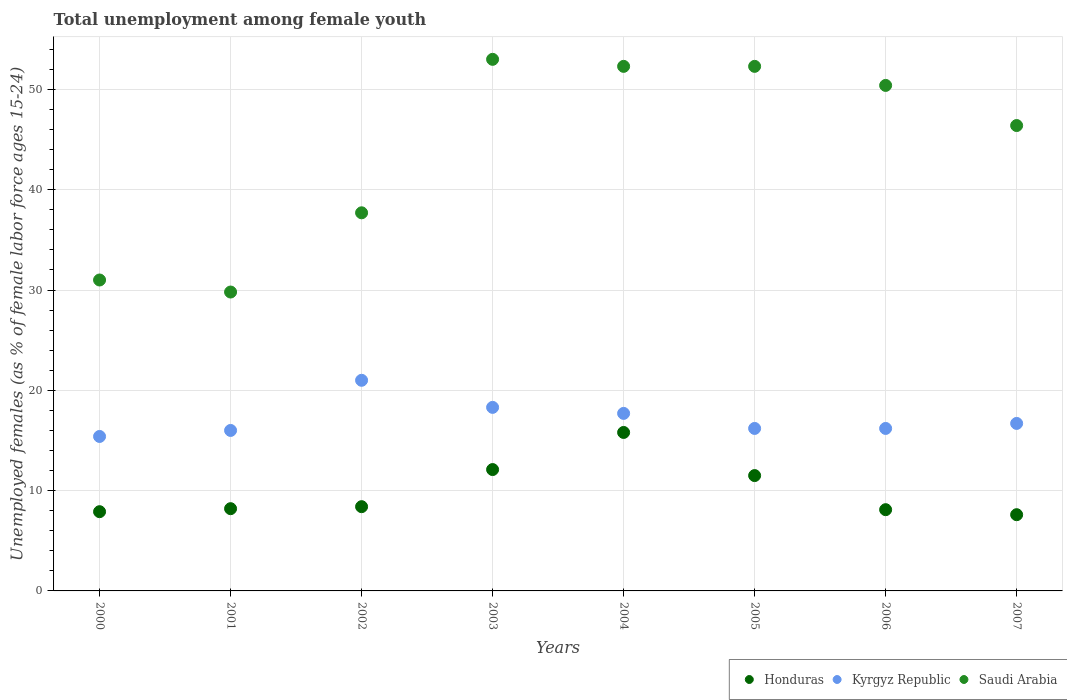How many different coloured dotlines are there?
Keep it short and to the point. 3. What is the percentage of unemployed females in in Kyrgyz Republic in 2004?
Offer a terse response. 17.7. Across all years, what is the maximum percentage of unemployed females in in Kyrgyz Republic?
Make the answer very short. 21. Across all years, what is the minimum percentage of unemployed females in in Kyrgyz Republic?
Ensure brevity in your answer.  15.4. What is the total percentage of unemployed females in in Honduras in the graph?
Provide a short and direct response. 79.6. What is the difference between the percentage of unemployed females in in Saudi Arabia in 2001 and that in 2002?
Ensure brevity in your answer.  -7.9. What is the average percentage of unemployed females in in Honduras per year?
Make the answer very short. 9.95. In the year 2002, what is the difference between the percentage of unemployed females in in Saudi Arabia and percentage of unemployed females in in Kyrgyz Republic?
Give a very brief answer. 16.7. What is the ratio of the percentage of unemployed females in in Saudi Arabia in 2004 to that in 2005?
Your response must be concise. 1. Is the percentage of unemployed females in in Kyrgyz Republic in 2003 less than that in 2005?
Your answer should be compact. No. Is the difference between the percentage of unemployed females in in Saudi Arabia in 2005 and 2006 greater than the difference between the percentage of unemployed females in in Kyrgyz Republic in 2005 and 2006?
Make the answer very short. Yes. What is the difference between the highest and the second highest percentage of unemployed females in in Kyrgyz Republic?
Your answer should be compact. 2.7. What is the difference between the highest and the lowest percentage of unemployed females in in Honduras?
Offer a terse response. 8.2. In how many years, is the percentage of unemployed females in in Honduras greater than the average percentage of unemployed females in in Honduras taken over all years?
Ensure brevity in your answer.  3. Does the percentage of unemployed females in in Kyrgyz Republic monotonically increase over the years?
Keep it short and to the point. No. Is the percentage of unemployed females in in Kyrgyz Republic strictly greater than the percentage of unemployed females in in Honduras over the years?
Offer a terse response. Yes. Is the percentage of unemployed females in in Saudi Arabia strictly less than the percentage of unemployed females in in Honduras over the years?
Provide a succinct answer. No. What is the difference between two consecutive major ticks on the Y-axis?
Ensure brevity in your answer.  10. Does the graph contain grids?
Give a very brief answer. Yes. How many legend labels are there?
Provide a succinct answer. 3. How are the legend labels stacked?
Offer a terse response. Horizontal. What is the title of the graph?
Your answer should be compact. Total unemployment among female youth. Does "Guinea" appear as one of the legend labels in the graph?
Your response must be concise. No. What is the label or title of the Y-axis?
Give a very brief answer. Unemployed females (as % of female labor force ages 15-24). What is the Unemployed females (as % of female labor force ages 15-24) in Honduras in 2000?
Provide a short and direct response. 7.9. What is the Unemployed females (as % of female labor force ages 15-24) in Kyrgyz Republic in 2000?
Provide a succinct answer. 15.4. What is the Unemployed females (as % of female labor force ages 15-24) of Honduras in 2001?
Provide a short and direct response. 8.2. What is the Unemployed females (as % of female labor force ages 15-24) of Saudi Arabia in 2001?
Ensure brevity in your answer.  29.8. What is the Unemployed females (as % of female labor force ages 15-24) in Honduras in 2002?
Give a very brief answer. 8.4. What is the Unemployed females (as % of female labor force ages 15-24) in Kyrgyz Republic in 2002?
Your response must be concise. 21. What is the Unemployed females (as % of female labor force ages 15-24) of Saudi Arabia in 2002?
Your answer should be compact. 37.7. What is the Unemployed females (as % of female labor force ages 15-24) in Honduras in 2003?
Your response must be concise. 12.1. What is the Unemployed females (as % of female labor force ages 15-24) in Kyrgyz Republic in 2003?
Ensure brevity in your answer.  18.3. What is the Unemployed females (as % of female labor force ages 15-24) in Saudi Arabia in 2003?
Keep it short and to the point. 53. What is the Unemployed females (as % of female labor force ages 15-24) of Honduras in 2004?
Provide a short and direct response. 15.8. What is the Unemployed females (as % of female labor force ages 15-24) of Kyrgyz Republic in 2004?
Give a very brief answer. 17.7. What is the Unemployed females (as % of female labor force ages 15-24) of Saudi Arabia in 2004?
Provide a succinct answer. 52.3. What is the Unemployed females (as % of female labor force ages 15-24) in Kyrgyz Republic in 2005?
Offer a very short reply. 16.2. What is the Unemployed females (as % of female labor force ages 15-24) of Saudi Arabia in 2005?
Keep it short and to the point. 52.3. What is the Unemployed females (as % of female labor force ages 15-24) of Honduras in 2006?
Provide a short and direct response. 8.1. What is the Unemployed females (as % of female labor force ages 15-24) in Kyrgyz Republic in 2006?
Provide a short and direct response. 16.2. What is the Unemployed females (as % of female labor force ages 15-24) of Saudi Arabia in 2006?
Your answer should be very brief. 50.4. What is the Unemployed females (as % of female labor force ages 15-24) in Honduras in 2007?
Your response must be concise. 7.6. What is the Unemployed females (as % of female labor force ages 15-24) of Kyrgyz Republic in 2007?
Provide a succinct answer. 16.7. What is the Unemployed females (as % of female labor force ages 15-24) in Saudi Arabia in 2007?
Make the answer very short. 46.4. Across all years, what is the maximum Unemployed females (as % of female labor force ages 15-24) in Honduras?
Ensure brevity in your answer.  15.8. Across all years, what is the maximum Unemployed females (as % of female labor force ages 15-24) in Kyrgyz Republic?
Your answer should be very brief. 21. Across all years, what is the maximum Unemployed females (as % of female labor force ages 15-24) in Saudi Arabia?
Keep it short and to the point. 53. Across all years, what is the minimum Unemployed females (as % of female labor force ages 15-24) in Honduras?
Your answer should be very brief. 7.6. Across all years, what is the minimum Unemployed females (as % of female labor force ages 15-24) in Kyrgyz Republic?
Give a very brief answer. 15.4. Across all years, what is the minimum Unemployed females (as % of female labor force ages 15-24) in Saudi Arabia?
Give a very brief answer. 29.8. What is the total Unemployed females (as % of female labor force ages 15-24) of Honduras in the graph?
Keep it short and to the point. 79.6. What is the total Unemployed females (as % of female labor force ages 15-24) of Kyrgyz Republic in the graph?
Your answer should be compact. 137.5. What is the total Unemployed females (as % of female labor force ages 15-24) of Saudi Arabia in the graph?
Ensure brevity in your answer.  352.9. What is the difference between the Unemployed females (as % of female labor force ages 15-24) of Honduras in 2000 and that in 2002?
Your response must be concise. -0.5. What is the difference between the Unemployed females (as % of female labor force ages 15-24) of Kyrgyz Republic in 2000 and that in 2002?
Your response must be concise. -5.6. What is the difference between the Unemployed females (as % of female labor force ages 15-24) of Saudi Arabia in 2000 and that in 2002?
Offer a very short reply. -6.7. What is the difference between the Unemployed females (as % of female labor force ages 15-24) of Honduras in 2000 and that in 2004?
Your answer should be very brief. -7.9. What is the difference between the Unemployed females (as % of female labor force ages 15-24) in Saudi Arabia in 2000 and that in 2004?
Give a very brief answer. -21.3. What is the difference between the Unemployed females (as % of female labor force ages 15-24) in Honduras in 2000 and that in 2005?
Make the answer very short. -3.6. What is the difference between the Unemployed females (as % of female labor force ages 15-24) in Kyrgyz Republic in 2000 and that in 2005?
Provide a short and direct response. -0.8. What is the difference between the Unemployed females (as % of female labor force ages 15-24) of Saudi Arabia in 2000 and that in 2005?
Make the answer very short. -21.3. What is the difference between the Unemployed females (as % of female labor force ages 15-24) in Honduras in 2000 and that in 2006?
Give a very brief answer. -0.2. What is the difference between the Unemployed females (as % of female labor force ages 15-24) of Saudi Arabia in 2000 and that in 2006?
Make the answer very short. -19.4. What is the difference between the Unemployed females (as % of female labor force ages 15-24) of Honduras in 2000 and that in 2007?
Your response must be concise. 0.3. What is the difference between the Unemployed females (as % of female labor force ages 15-24) in Saudi Arabia in 2000 and that in 2007?
Provide a succinct answer. -15.4. What is the difference between the Unemployed females (as % of female labor force ages 15-24) of Kyrgyz Republic in 2001 and that in 2002?
Your response must be concise. -5. What is the difference between the Unemployed females (as % of female labor force ages 15-24) of Honduras in 2001 and that in 2003?
Provide a short and direct response. -3.9. What is the difference between the Unemployed females (as % of female labor force ages 15-24) in Saudi Arabia in 2001 and that in 2003?
Make the answer very short. -23.2. What is the difference between the Unemployed females (as % of female labor force ages 15-24) in Honduras in 2001 and that in 2004?
Your response must be concise. -7.6. What is the difference between the Unemployed females (as % of female labor force ages 15-24) in Saudi Arabia in 2001 and that in 2004?
Ensure brevity in your answer.  -22.5. What is the difference between the Unemployed females (as % of female labor force ages 15-24) in Saudi Arabia in 2001 and that in 2005?
Provide a short and direct response. -22.5. What is the difference between the Unemployed females (as % of female labor force ages 15-24) in Honduras in 2001 and that in 2006?
Give a very brief answer. 0.1. What is the difference between the Unemployed females (as % of female labor force ages 15-24) of Kyrgyz Republic in 2001 and that in 2006?
Offer a terse response. -0.2. What is the difference between the Unemployed females (as % of female labor force ages 15-24) of Saudi Arabia in 2001 and that in 2006?
Your answer should be compact. -20.6. What is the difference between the Unemployed females (as % of female labor force ages 15-24) of Honduras in 2001 and that in 2007?
Offer a very short reply. 0.6. What is the difference between the Unemployed females (as % of female labor force ages 15-24) in Kyrgyz Republic in 2001 and that in 2007?
Offer a very short reply. -0.7. What is the difference between the Unemployed females (as % of female labor force ages 15-24) of Saudi Arabia in 2001 and that in 2007?
Your response must be concise. -16.6. What is the difference between the Unemployed females (as % of female labor force ages 15-24) in Honduras in 2002 and that in 2003?
Offer a very short reply. -3.7. What is the difference between the Unemployed females (as % of female labor force ages 15-24) in Kyrgyz Republic in 2002 and that in 2003?
Offer a very short reply. 2.7. What is the difference between the Unemployed females (as % of female labor force ages 15-24) of Saudi Arabia in 2002 and that in 2003?
Ensure brevity in your answer.  -15.3. What is the difference between the Unemployed females (as % of female labor force ages 15-24) in Kyrgyz Republic in 2002 and that in 2004?
Your answer should be very brief. 3.3. What is the difference between the Unemployed females (as % of female labor force ages 15-24) of Saudi Arabia in 2002 and that in 2004?
Your answer should be very brief. -14.6. What is the difference between the Unemployed females (as % of female labor force ages 15-24) of Kyrgyz Republic in 2002 and that in 2005?
Keep it short and to the point. 4.8. What is the difference between the Unemployed females (as % of female labor force ages 15-24) in Saudi Arabia in 2002 and that in 2005?
Offer a very short reply. -14.6. What is the difference between the Unemployed females (as % of female labor force ages 15-24) of Saudi Arabia in 2002 and that in 2006?
Ensure brevity in your answer.  -12.7. What is the difference between the Unemployed females (as % of female labor force ages 15-24) in Saudi Arabia in 2002 and that in 2007?
Give a very brief answer. -8.7. What is the difference between the Unemployed females (as % of female labor force ages 15-24) in Kyrgyz Republic in 2003 and that in 2004?
Give a very brief answer. 0.6. What is the difference between the Unemployed females (as % of female labor force ages 15-24) in Kyrgyz Republic in 2003 and that in 2005?
Offer a terse response. 2.1. What is the difference between the Unemployed females (as % of female labor force ages 15-24) in Saudi Arabia in 2003 and that in 2005?
Give a very brief answer. 0.7. What is the difference between the Unemployed females (as % of female labor force ages 15-24) of Saudi Arabia in 2003 and that in 2006?
Your answer should be compact. 2.6. What is the difference between the Unemployed females (as % of female labor force ages 15-24) of Honduras in 2003 and that in 2007?
Provide a succinct answer. 4.5. What is the difference between the Unemployed females (as % of female labor force ages 15-24) in Saudi Arabia in 2003 and that in 2007?
Provide a succinct answer. 6.6. What is the difference between the Unemployed females (as % of female labor force ages 15-24) of Honduras in 2004 and that in 2005?
Provide a short and direct response. 4.3. What is the difference between the Unemployed females (as % of female labor force ages 15-24) in Honduras in 2004 and that in 2006?
Keep it short and to the point. 7.7. What is the difference between the Unemployed females (as % of female labor force ages 15-24) of Kyrgyz Republic in 2004 and that in 2006?
Provide a short and direct response. 1.5. What is the difference between the Unemployed females (as % of female labor force ages 15-24) in Saudi Arabia in 2004 and that in 2006?
Your answer should be very brief. 1.9. What is the difference between the Unemployed females (as % of female labor force ages 15-24) in Honduras in 2004 and that in 2007?
Your answer should be very brief. 8.2. What is the difference between the Unemployed females (as % of female labor force ages 15-24) in Kyrgyz Republic in 2004 and that in 2007?
Offer a terse response. 1. What is the difference between the Unemployed females (as % of female labor force ages 15-24) of Saudi Arabia in 2004 and that in 2007?
Ensure brevity in your answer.  5.9. What is the difference between the Unemployed females (as % of female labor force ages 15-24) of Kyrgyz Republic in 2005 and that in 2006?
Provide a succinct answer. 0. What is the difference between the Unemployed females (as % of female labor force ages 15-24) in Honduras in 2005 and that in 2007?
Give a very brief answer. 3.9. What is the difference between the Unemployed females (as % of female labor force ages 15-24) in Kyrgyz Republic in 2005 and that in 2007?
Offer a very short reply. -0.5. What is the difference between the Unemployed females (as % of female labor force ages 15-24) of Kyrgyz Republic in 2006 and that in 2007?
Provide a short and direct response. -0.5. What is the difference between the Unemployed females (as % of female labor force ages 15-24) in Honduras in 2000 and the Unemployed females (as % of female labor force ages 15-24) in Saudi Arabia in 2001?
Ensure brevity in your answer.  -21.9. What is the difference between the Unemployed females (as % of female labor force ages 15-24) in Kyrgyz Republic in 2000 and the Unemployed females (as % of female labor force ages 15-24) in Saudi Arabia in 2001?
Provide a short and direct response. -14.4. What is the difference between the Unemployed females (as % of female labor force ages 15-24) in Honduras in 2000 and the Unemployed females (as % of female labor force ages 15-24) in Saudi Arabia in 2002?
Your answer should be compact. -29.8. What is the difference between the Unemployed females (as % of female labor force ages 15-24) of Kyrgyz Republic in 2000 and the Unemployed females (as % of female labor force ages 15-24) of Saudi Arabia in 2002?
Provide a succinct answer. -22.3. What is the difference between the Unemployed females (as % of female labor force ages 15-24) of Honduras in 2000 and the Unemployed females (as % of female labor force ages 15-24) of Kyrgyz Republic in 2003?
Make the answer very short. -10.4. What is the difference between the Unemployed females (as % of female labor force ages 15-24) of Honduras in 2000 and the Unemployed females (as % of female labor force ages 15-24) of Saudi Arabia in 2003?
Your answer should be compact. -45.1. What is the difference between the Unemployed females (as % of female labor force ages 15-24) of Kyrgyz Republic in 2000 and the Unemployed females (as % of female labor force ages 15-24) of Saudi Arabia in 2003?
Provide a short and direct response. -37.6. What is the difference between the Unemployed females (as % of female labor force ages 15-24) of Honduras in 2000 and the Unemployed females (as % of female labor force ages 15-24) of Saudi Arabia in 2004?
Give a very brief answer. -44.4. What is the difference between the Unemployed females (as % of female labor force ages 15-24) in Kyrgyz Republic in 2000 and the Unemployed females (as % of female labor force ages 15-24) in Saudi Arabia in 2004?
Provide a succinct answer. -36.9. What is the difference between the Unemployed females (as % of female labor force ages 15-24) in Honduras in 2000 and the Unemployed females (as % of female labor force ages 15-24) in Kyrgyz Republic in 2005?
Make the answer very short. -8.3. What is the difference between the Unemployed females (as % of female labor force ages 15-24) of Honduras in 2000 and the Unemployed females (as % of female labor force ages 15-24) of Saudi Arabia in 2005?
Your response must be concise. -44.4. What is the difference between the Unemployed females (as % of female labor force ages 15-24) in Kyrgyz Republic in 2000 and the Unemployed females (as % of female labor force ages 15-24) in Saudi Arabia in 2005?
Keep it short and to the point. -36.9. What is the difference between the Unemployed females (as % of female labor force ages 15-24) in Honduras in 2000 and the Unemployed females (as % of female labor force ages 15-24) in Kyrgyz Republic in 2006?
Provide a short and direct response. -8.3. What is the difference between the Unemployed females (as % of female labor force ages 15-24) in Honduras in 2000 and the Unemployed females (as % of female labor force ages 15-24) in Saudi Arabia in 2006?
Your response must be concise. -42.5. What is the difference between the Unemployed females (as % of female labor force ages 15-24) of Kyrgyz Republic in 2000 and the Unemployed females (as % of female labor force ages 15-24) of Saudi Arabia in 2006?
Keep it short and to the point. -35. What is the difference between the Unemployed females (as % of female labor force ages 15-24) of Honduras in 2000 and the Unemployed females (as % of female labor force ages 15-24) of Kyrgyz Republic in 2007?
Your answer should be very brief. -8.8. What is the difference between the Unemployed females (as % of female labor force ages 15-24) of Honduras in 2000 and the Unemployed females (as % of female labor force ages 15-24) of Saudi Arabia in 2007?
Offer a terse response. -38.5. What is the difference between the Unemployed females (as % of female labor force ages 15-24) of Kyrgyz Republic in 2000 and the Unemployed females (as % of female labor force ages 15-24) of Saudi Arabia in 2007?
Ensure brevity in your answer.  -31. What is the difference between the Unemployed females (as % of female labor force ages 15-24) of Honduras in 2001 and the Unemployed females (as % of female labor force ages 15-24) of Saudi Arabia in 2002?
Offer a terse response. -29.5. What is the difference between the Unemployed females (as % of female labor force ages 15-24) of Kyrgyz Republic in 2001 and the Unemployed females (as % of female labor force ages 15-24) of Saudi Arabia in 2002?
Offer a terse response. -21.7. What is the difference between the Unemployed females (as % of female labor force ages 15-24) of Honduras in 2001 and the Unemployed females (as % of female labor force ages 15-24) of Kyrgyz Republic in 2003?
Keep it short and to the point. -10.1. What is the difference between the Unemployed females (as % of female labor force ages 15-24) in Honduras in 2001 and the Unemployed females (as % of female labor force ages 15-24) in Saudi Arabia in 2003?
Make the answer very short. -44.8. What is the difference between the Unemployed females (as % of female labor force ages 15-24) in Kyrgyz Republic in 2001 and the Unemployed females (as % of female labor force ages 15-24) in Saudi Arabia in 2003?
Offer a terse response. -37. What is the difference between the Unemployed females (as % of female labor force ages 15-24) in Honduras in 2001 and the Unemployed females (as % of female labor force ages 15-24) in Kyrgyz Republic in 2004?
Your answer should be compact. -9.5. What is the difference between the Unemployed females (as % of female labor force ages 15-24) of Honduras in 2001 and the Unemployed females (as % of female labor force ages 15-24) of Saudi Arabia in 2004?
Your answer should be compact. -44.1. What is the difference between the Unemployed females (as % of female labor force ages 15-24) of Kyrgyz Republic in 2001 and the Unemployed females (as % of female labor force ages 15-24) of Saudi Arabia in 2004?
Keep it short and to the point. -36.3. What is the difference between the Unemployed females (as % of female labor force ages 15-24) in Honduras in 2001 and the Unemployed females (as % of female labor force ages 15-24) in Saudi Arabia in 2005?
Ensure brevity in your answer.  -44.1. What is the difference between the Unemployed females (as % of female labor force ages 15-24) in Kyrgyz Republic in 2001 and the Unemployed females (as % of female labor force ages 15-24) in Saudi Arabia in 2005?
Keep it short and to the point. -36.3. What is the difference between the Unemployed females (as % of female labor force ages 15-24) in Honduras in 2001 and the Unemployed females (as % of female labor force ages 15-24) in Saudi Arabia in 2006?
Provide a succinct answer. -42.2. What is the difference between the Unemployed females (as % of female labor force ages 15-24) in Kyrgyz Republic in 2001 and the Unemployed females (as % of female labor force ages 15-24) in Saudi Arabia in 2006?
Your answer should be very brief. -34.4. What is the difference between the Unemployed females (as % of female labor force ages 15-24) in Honduras in 2001 and the Unemployed females (as % of female labor force ages 15-24) in Saudi Arabia in 2007?
Ensure brevity in your answer.  -38.2. What is the difference between the Unemployed females (as % of female labor force ages 15-24) in Kyrgyz Republic in 2001 and the Unemployed females (as % of female labor force ages 15-24) in Saudi Arabia in 2007?
Offer a very short reply. -30.4. What is the difference between the Unemployed females (as % of female labor force ages 15-24) of Honduras in 2002 and the Unemployed females (as % of female labor force ages 15-24) of Kyrgyz Republic in 2003?
Your answer should be compact. -9.9. What is the difference between the Unemployed females (as % of female labor force ages 15-24) in Honduras in 2002 and the Unemployed females (as % of female labor force ages 15-24) in Saudi Arabia in 2003?
Provide a short and direct response. -44.6. What is the difference between the Unemployed females (as % of female labor force ages 15-24) of Kyrgyz Republic in 2002 and the Unemployed females (as % of female labor force ages 15-24) of Saudi Arabia in 2003?
Provide a succinct answer. -32. What is the difference between the Unemployed females (as % of female labor force ages 15-24) of Honduras in 2002 and the Unemployed females (as % of female labor force ages 15-24) of Kyrgyz Republic in 2004?
Your answer should be very brief. -9.3. What is the difference between the Unemployed females (as % of female labor force ages 15-24) in Honduras in 2002 and the Unemployed females (as % of female labor force ages 15-24) in Saudi Arabia in 2004?
Offer a terse response. -43.9. What is the difference between the Unemployed females (as % of female labor force ages 15-24) in Kyrgyz Republic in 2002 and the Unemployed females (as % of female labor force ages 15-24) in Saudi Arabia in 2004?
Offer a terse response. -31.3. What is the difference between the Unemployed females (as % of female labor force ages 15-24) of Honduras in 2002 and the Unemployed females (as % of female labor force ages 15-24) of Kyrgyz Republic in 2005?
Ensure brevity in your answer.  -7.8. What is the difference between the Unemployed females (as % of female labor force ages 15-24) of Honduras in 2002 and the Unemployed females (as % of female labor force ages 15-24) of Saudi Arabia in 2005?
Your answer should be compact. -43.9. What is the difference between the Unemployed females (as % of female labor force ages 15-24) in Kyrgyz Republic in 2002 and the Unemployed females (as % of female labor force ages 15-24) in Saudi Arabia in 2005?
Your response must be concise. -31.3. What is the difference between the Unemployed females (as % of female labor force ages 15-24) of Honduras in 2002 and the Unemployed females (as % of female labor force ages 15-24) of Saudi Arabia in 2006?
Your response must be concise. -42. What is the difference between the Unemployed females (as % of female labor force ages 15-24) in Kyrgyz Republic in 2002 and the Unemployed females (as % of female labor force ages 15-24) in Saudi Arabia in 2006?
Your answer should be very brief. -29.4. What is the difference between the Unemployed females (as % of female labor force ages 15-24) in Honduras in 2002 and the Unemployed females (as % of female labor force ages 15-24) in Kyrgyz Republic in 2007?
Make the answer very short. -8.3. What is the difference between the Unemployed females (as % of female labor force ages 15-24) in Honduras in 2002 and the Unemployed females (as % of female labor force ages 15-24) in Saudi Arabia in 2007?
Give a very brief answer. -38. What is the difference between the Unemployed females (as % of female labor force ages 15-24) of Kyrgyz Republic in 2002 and the Unemployed females (as % of female labor force ages 15-24) of Saudi Arabia in 2007?
Your answer should be compact. -25.4. What is the difference between the Unemployed females (as % of female labor force ages 15-24) in Honduras in 2003 and the Unemployed females (as % of female labor force ages 15-24) in Saudi Arabia in 2004?
Offer a terse response. -40.2. What is the difference between the Unemployed females (as % of female labor force ages 15-24) of Kyrgyz Republic in 2003 and the Unemployed females (as % of female labor force ages 15-24) of Saudi Arabia in 2004?
Give a very brief answer. -34. What is the difference between the Unemployed females (as % of female labor force ages 15-24) of Honduras in 2003 and the Unemployed females (as % of female labor force ages 15-24) of Kyrgyz Republic in 2005?
Ensure brevity in your answer.  -4.1. What is the difference between the Unemployed females (as % of female labor force ages 15-24) of Honduras in 2003 and the Unemployed females (as % of female labor force ages 15-24) of Saudi Arabia in 2005?
Your answer should be very brief. -40.2. What is the difference between the Unemployed females (as % of female labor force ages 15-24) in Kyrgyz Republic in 2003 and the Unemployed females (as % of female labor force ages 15-24) in Saudi Arabia in 2005?
Your answer should be very brief. -34. What is the difference between the Unemployed females (as % of female labor force ages 15-24) in Honduras in 2003 and the Unemployed females (as % of female labor force ages 15-24) in Kyrgyz Republic in 2006?
Offer a terse response. -4.1. What is the difference between the Unemployed females (as % of female labor force ages 15-24) in Honduras in 2003 and the Unemployed females (as % of female labor force ages 15-24) in Saudi Arabia in 2006?
Make the answer very short. -38.3. What is the difference between the Unemployed females (as % of female labor force ages 15-24) of Kyrgyz Republic in 2003 and the Unemployed females (as % of female labor force ages 15-24) of Saudi Arabia in 2006?
Offer a terse response. -32.1. What is the difference between the Unemployed females (as % of female labor force ages 15-24) of Honduras in 2003 and the Unemployed females (as % of female labor force ages 15-24) of Kyrgyz Republic in 2007?
Your response must be concise. -4.6. What is the difference between the Unemployed females (as % of female labor force ages 15-24) of Honduras in 2003 and the Unemployed females (as % of female labor force ages 15-24) of Saudi Arabia in 2007?
Your response must be concise. -34.3. What is the difference between the Unemployed females (as % of female labor force ages 15-24) in Kyrgyz Republic in 2003 and the Unemployed females (as % of female labor force ages 15-24) in Saudi Arabia in 2007?
Your response must be concise. -28.1. What is the difference between the Unemployed females (as % of female labor force ages 15-24) of Honduras in 2004 and the Unemployed females (as % of female labor force ages 15-24) of Saudi Arabia in 2005?
Your answer should be compact. -36.5. What is the difference between the Unemployed females (as % of female labor force ages 15-24) of Kyrgyz Republic in 2004 and the Unemployed females (as % of female labor force ages 15-24) of Saudi Arabia in 2005?
Ensure brevity in your answer.  -34.6. What is the difference between the Unemployed females (as % of female labor force ages 15-24) of Honduras in 2004 and the Unemployed females (as % of female labor force ages 15-24) of Saudi Arabia in 2006?
Provide a succinct answer. -34.6. What is the difference between the Unemployed females (as % of female labor force ages 15-24) of Kyrgyz Republic in 2004 and the Unemployed females (as % of female labor force ages 15-24) of Saudi Arabia in 2006?
Your answer should be compact. -32.7. What is the difference between the Unemployed females (as % of female labor force ages 15-24) in Honduras in 2004 and the Unemployed females (as % of female labor force ages 15-24) in Saudi Arabia in 2007?
Your response must be concise. -30.6. What is the difference between the Unemployed females (as % of female labor force ages 15-24) in Kyrgyz Republic in 2004 and the Unemployed females (as % of female labor force ages 15-24) in Saudi Arabia in 2007?
Keep it short and to the point. -28.7. What is the difference between the Unemployed females (as % of female labor force ages 15-24) in Honduras in 2005 and the Unemployed females (as % of female labor force ages 15-24) in Kyrgyz Republic in 2006?
Provide a succinct answer. -4.7. What is the difference between the Unemployed females (as % of female labor force ages 15-24) in Honduras in 2005 and the Unemployed females (as % of female labor force ages 15-24) in Saudi Arabia in 2006?
Offer a terse response. -38.9. What is the difference between the Unemployed females (as % of female labor force ages 15-24) in Kyrgyz Republic in 2005 and the Unemployed females (as % of female labor force ages 15-24) in Saudi Arabia in 2006?
Offer a terse response. -34.2. What is the difference between the Unemployed females (as % of female labor force ages 15-24) of Honduras in 2005 and the Unemployed females (as % of female labor force ages 15-24) of Kyrgyz Republic in 2007?
Your response must be concise. -5.2. What is the difference between the Unemployed females (as % of female labor force ages 15-24) of Honduras in 2005 and the Unemployed females (as % of female labor force ages 15-24) of Saudi Arabia in 2007?
Ensure brevity in your answer.  -34.9. What is the difference between the Unemployed females (as % of female labor force ages 15-24) of Kyrgyz Republic in 2005 and the Unemployed females (as % of female labor force ages 15-24) of Saudi Arabia in 2007?
Ensure brevity in your answer.  -30.2. What is the difference between the Unemployed females (as % of female labor force ages 15-24) of Honduras in 2006 and the Unemployed females (as % of female labor force ages 15-24) of Kyrgyz Republic in 2007?
Make the answer very short. -8.6. What is the difference between the Unemployed females (as % of female labor force ages 15-24) of Honduras in 2006 and the Unemployed females (as % of female labor force ages 15-24) of Saudi Arabia in 2007?
Ensure brevity in your answer.  -38.3. What is the difference between the Unemployed females (as % of female labor force ages 15-24) of Kyrgyz Republic in 2006 and the Unemployed females (as % of female labor force ages 15-24) of Saudi Arabia in 2007?
Your answer should be very brief. -30.2. What is the average Unemployed females (as % of female labor force ages 15-24) in Honduras per year?
Provide a short and direct response. 9.95. What is the average Unemployed females (as % of female labor force ages 15-24) in Kyrgyz Republic per year?
Your answer should be very brief. 17.19. What is the average Unemployed females (as % of female labor force ages 15-24) of Saudi Arabia per year?
Ensure brevity in your answer.  44.11. In the year 2000, what is the difference between the Unemployed females (as % of female labor force ages 15-24) in Honduras and Unemployed females (as % of female labor force ages 15-24) in Saudi Arabia?
Ensure brevity in your answer.  -23.1. In the year 2000, what is the difference between the Unemployed females (as % of female labor force ages 15-24) of Kyrgyz Republic and Unemployed females (as % of female labor force ages 15-24) of Saudi Arabia?
Offer a very short reply. -15.6. In the year 2001, what is the difference between the Unemployed females (as % of female labor force ages 15-24) in Honduras and Unemployed females (as % of female labor force ages 15-24) in Saudi Arabia?
Give a very brief answer. -21.6. In the year 2002, what is the difference between the Unemployed females (as % of female labor force ages 15-24) of Honduras and Unemployed females (as % of female labor force ages 15-24) of Kyrgyz Republic?
Your answer should be very brief. -12.6. In the year 2002, what is the difference between the Unemployed females (as % of female labor force ages 15-24) of Honduras and Unemployed females (as % of female labor force ages 15-24) of Saudi Arabia?
Make the answer very short. -29.3. In the year 2002, what is the difference between the Unemployed females (as % of female labor force ages 15-24) of Kyrgyz Republic and Unemployed females (as % of female labor force ages 15-24) of Saudi Arabia?
Offer a terse response. -16.7. In the year 2003, what is the difference between the Unemployed females (as % of female labor force ages 15-24) of Honduras and Unemployed females (as % of female labor force ages 15-24) of Saudi Arabia?
Your response must be concise. -40.9. In the year 2003, what is the difference between the Unemployed females (as % of female labor force ages 15-24) of Kyrgyz Republic and Unemployed females (as % of female labor force ages 15-24) of Saudi Arabia?
Offer a terse response. -34.7. In the year 2004, what is the difference between the Unemployed females (as % of female labor force ages 15-24) of Honduras and Unemployed females (as % of female labor force ages 15-24) of Saudi Arabia?
Ensure brevity in your answer.  -36.5. In the year 2004, what is the difference between the Unemployed females (as % of female labor force ages 15-24) in Kyrgyz Republic and Unemployed females (as % of female labor force ages 15-24) in Saudi Arabia?
Provide a succinct answer. -34.6. In the year 2005, what is the difference between the Unemployed females (as % of female labor force ages 15-24) of Honduras and Unemployed females (as % of female labor force ages 15-24) of Kyrgyz Republic?
Your answer should be compact. -4.7. In the year 2005, what is the difference between the Unemployed females (as % of female labor force ages 15-24) of Honduras and Unemployed females (as % of female labor force ages 15-24) of Saudi Arabia?
Provide a succinct answer. -40.8. In the year 2005, what is the difference between the Unemployed females (as % of female labor force ages 15-24) of Kyrgyz Republic and Unemployed females (as % of female labor force ages 15-24) of Saudi Arabia?
Provide a short and direct response. -36.1. In the year 2006, what is the difference between the Unemployed females (as % of female labor force ages 15-24) in Honduras and Unemployed females (as % of female labor force ages 15-24) in Kyrgyz Republic?
Give a very brief answer. -8.1. In the year 2006, what is the difference between the Unemployed females (as % of female labor force ages 15-24) in Honduras and Unemployed females (as % of female labor force ages 15-24) in Saudi Arabia?
Provide a short and direct response. -42.3. In the year 2006, what is the difference between the Unemployed females (as % of female labor force ages 15-24) of Kyrgyz Republic and Unemployed females (as % of female labor force ages 15-24) of Saudi Arabia?
Give a very brief answer. -34.2. In the year 2007, what is the difference between the Unemployed females (as % of female labor force ages 15-24) of Honduras and Unemployed females (as % of female labor force ages 15-24) of Saudi Arabia?
Keep it short and to the point. -38.8. In the year 2007, what is the difference between the Unemployed females (as % of female labor force ages 15-24) in Kyrgyz Republic and Unemployed females (as % of female labor force ages 15-24) in Saudi Arabia?
Offer a very short reply. -29.7. What is the ratio of the Unemployed females (as % of female labor force ages 15-24) in Honduras in 2000 to that in 2001?
Offer a terse response. 0.96. What is the ratio of the Unemployed females (as % of female labor force ages 15-24) in Kyrgyz Republic in 2000 to that in 2001?
Keep it short and to the point. 0.96. What is the ratio of the Unemployed females (as % of female labor force ages 15-24) of Saudi Arabia in 2000 to that in 2001?
Offer a terse response. 1.04. What is the ratio of the Unemployed females (as % of female labor force ages 15-24) in Honduras in 2000 to that in 2002?
Your response must be concise. 0.94. What is the ratio of the Unemployed females (as % of female labor force ages 15-24) of Kyrgyz Republic in 2000 to that in 2002?
Your answer should be very brief. 0.73. What is the ratio of the Unemployed females (as % of female labor force ages 15-24) of Saudi Arabia in 2000 to that in 2002?
Give a very brief answer. 0.82. What is the ratio of the Unemployed females (as % of female labor force ages 15-24) of Honduras in 2000 to that in 2003?
Ensure brevity in your answer.  0.65. What is the ratio of the Unemployed females (as % of female labor force ages 15-24) in Kyrgyz Republic in 2000 to that in 2003?
Ensure brevity in your answer.  0.84. What is the ratio of the Unemployed females (as % of female labor force ages 15-24) of Saudi Arabia in 2000 to that in 2003?
Offer a terse response. 0.58. What is the ratio of the Unemployed females (as % of female labor force ages 15-24) in Kyrgyz Republic in 2000 to that in 2004?
Ensure brevity in your answer.  0.87. What is the ratio of the Unemployed females (as % of female labor force ages 15-24) of Saudi Arabia in 2000 to that in 2004?
Provide a succinct answer. 0.59. What is the ratio of the Unemployed females (as % of female labor force ages 15-24) of Honduras in 2000 to that in 2005?
Your response must be concise. 0.69. What is the ratio of the Unemployed females (as % of female labor force ages 15-24) of Kyrgyz Republic in 2000 to that in 2005?
Keep it short and to the point. 0.95. What is the ratio of the Unemployed females (as % of female labor force ages 15-24) in Saudi Arabia in 2000 to that in 2005?
Your answer should be very brief. 0.59. What is the ratio of the Unemployed females (as % of female labor force ages 15-24) in Honduras in 2000 to that in 2006?
Provide a short and direct response. 0.98. What is the ratio of the Unemployed females (as % of female labor force ages 15-24) of Kyrgyz Republic in 2000 to that in 2006?
Make the answer very short. 0.95. What is the ratio of the Unemployed females (as % of female labor force ages 15-24) of Saudi Arabia in 2000 to that in 2006?
Offer a terse response. 0.62. What is the ratio of the Unemployed females (as % of female labor force ages 15-24) of Honduras in 2000 to that in 2007?
Your response must be concise. 1.04. What is the ratio of the Unemployed females (as % of female labor force ages 15-24) in Kyrgyz Republic in 2000 to that in 2007?
Your answer should be compact. 0.92. What is the ratio of the Unemployed females (as % of female labor force ages 15-24) of Saudi Arabia in 2000 to that in 2007?
Your response must be concise. 0.67. What is the ratio of the Unemployed females (as % of female labor force ages 15-24) in Honduras in 2001 to that in 2002?
Make the answer very short. 0.98. What is the ratio of the Unemployed females (as % of female labor force ages 15-24) in Kyrgyz Republic in 2001 to that in 2002?
Your answer should be compact. 0.76. What is the ratio of the Unemployed females (as % of female labor force ages 15-24) of Saudi Arabia in 2001 to that in 2002?
Ensure brevity in your answer.  0.79. What is the ratio of the Unemployed females (as % of female labor force ages 15-24) in Honduras in 2001 to that in 2003?
Keep it short and to the point. 0.68. What is the ratio of the Unemployed females (as % of female labor force ages 15-24) of Kyrgyz Republic in 2001 to that in 2003?
Keep it short and to the point. 0.87. What is the ratio of the Unemployed females (as % of female labor force ages 15-24) of Saudi Arabia in 2001 to that in 2003?
Keep it short and to the point. 0.56. What is the ratio of the Unemployed females (as % of female labor force ages 15-24) of Honduras in 2001 to that in 2004?
Provide a succinct answer. 0.52. What is the ratio of the Unemployed females (as % of female labor force ages 15-24) in Kyrgyz Republic in 2001 to that in 2004?
Your answer should be compact. 0.9. What is the ratio of the Unemployed females (as % of female labor force ages 15-24) of Saudi Arabia in 2001 to that in 2004?
Offer a terse response. 0.57. What is the ratio of the Unemployed females (as % of female labor force ages 15-24) of Honduras in 2001 to that in 2005?
Give a very brief answer. 0.71. What is the ratio of the Unemployed females (as % of female labor force ages 15-24) in Kyrgyz Republic in 2001 to that in 2005?
Provide a short and direct response. 0.99. What is the ratio of the Unemployed females (as % of female labor force ages 15-24) in Saudi Arabia in 2001 to that in 2005?
Provide a short and direct response. 0.57. What is the ratio of the Unemployed females (as % of female labor force ages 15-24) of Honduras in 2001 to that in 2006?
Your answer should be compact. 1.01. What is the ratio of the Unemployed females (as % of female labor force ages 15-24) of Saudi Arabia in 2001 to that in 2006?
Ensure brevity in your answer.  0.59. What is the ratio of the Unemployed females (as % of female labor force ages 15-24) in Honduras in 2001 to that in 2007?
Give a very brief answer. 1.08. What is the ratio of the Unemployed females (as % of female labor force ages 15-24) of Kyrgyz Republic in 2001 to that in 2007?
Ensure brevity in your answer.  0.96. What is the ratio of the Unemployed females (as % of female labor force ages 15-24) of Saudi Arabia in 2001 to that in 2007?
Offer a terse response. 0.64. What is the ratio of the Unemployed females (as % of female labor force ages 15-24) in Honduras in 2002 to that in 2003?
Offer a terse response. 0.69. What is the ratio of the Unemployed females (as % of female labor force ages 15-24) of Kyrgyz Republic in 2002 to that in 2003?
Provide a succinct answer. 1.15. What is the ratio of the Unemployed females (as % of female labor force ages 15-24) of Saudi Arabia in 2002 to that in 2003?
Your answer should be very brief. 0.71. What is the ratio of the Unemployed females (as % of female labor force ages 15-24) of Honduras in 2002 to that in 2004?
Provide a short and direct response. 0.53. What is the ratio of the Unemployed females (as % of female labor force ages 15-24) in Kyrgyz Republic in 2002 to that in 2004?
Your answer should be very brief. 1.19. What is the ratio of the Unemployed females (as % of female labor force ages 15-24) in Saudi Arabia in 2002 to that in 2004?
Provide a succinct answer. 0.72. What is the ratio of the Unemployed females (as % of female labor force ages 15-24) of Honduras in 2002 to that in 2005?
Your answer should be very brief. 0.73. What is the ratio of the Unemployed females (as % of female labor force ages 15-24) in Kyrgyz Republic in 2002 to that in 2005?
Provide a short and direct response. 1.3. What is the ratio of the Unemployed females (as % of female labor force ages 15-24) of Saudi Arabia in 2002 to that in 2005?
Your response must be concise. 0.72. What is the ratio of the Unemployed females (as % of female labor force ages 15-24) of Honduras in 2002 to that in 2006?
Give a very brief answer. 1.04. What is the ratio of the Unemployed females (as % of female labor force ages 15-24) of Kyrgyz Republic in 2002 to that in 2006?
Make the answer very short. 1.3. What is the ratio of the Unemployed females (as % of female labor force ages 15-24) in Saudi Arabia in 2002 to that in 2006?
Give a very brief answer. 0.75. What is the ratio of the Unemployed females (as % of female labor force ages 15-24) of Honduras in 2002 to that in 2007?
Provide a short and direct response. 1.11. What is the ratio of the Unemployed females (as % of female labor force ages 15-24) of Kyrgyz Republic in 2002 to that in 2007?
Keep it short and to the point. 1.26. What is the ratio of the Unemployed females (as % of female labor force ages 15-24) in Saudi Arabia in 2002 to that in 2007?
Offer a very short reply. 0.81. What is the ratio of the Unemployed females (as % of female labor force ages 15-24) in Honduras in 2003 to that in 2004?
Keep it short and to the point. 0.77. What is the ratio of the Unemployed females (as % of female labor force ages 15-24) of Kyrgyz Republic in 2003 to that in 2004?
Ensure brevity in your answer.  1.03. What is the ratio of the Unemployed females (as % of female labor force ages 15-24) of Saudi Arabia in 2003 to that in 2004?
Offer a very short reply. 1.01. What is the ratio of the Unemployed females (as % of female labor force ages 15-24) of Honduras in 2003 to that in 2005?
Ensure brevity in your answer.  1.05. What is the ratio of the Unemployed females (as % of female labor force ages 15-24) of Kyrgyz Republic in 2003 to that in 2005?
Provide a short and direct response. 1.13. What is the ratio of the Unemployed females (as % of female labor force ages 15-24) of Saudi Arabia in 2003 to that in 2005?
Offer a very short reply. 1.01. What is the ratio of the Unemployed females (as % of female labor force ages 15-24) in Honduras in 2003 to that in 2006?
Provide a short and direct response. 1.49. What is the ratio of the Unemployed females (as % of female labor force ages 15-24) of Kyrgyz Republic in 2003 to that in 2006?
Your answer should be very brief. 1.13. What is the ratio of the Unemployed females (as % of female labor force ages 15-24) in Saudi Arabia in 2003 to that in 2006?
Your response must be concise. 1.05. What is the ratio of the Unemployed females (as % of female labor force ages 15-24) of Honduras in 2003 to that in 2007?
Your answer should be very brief. 1.59. What is the ratio of the Unemployed females (as % of female labor force ages 15-24) of Kyrgyz Republic in 2003 to that in 2007?
Offer a terse response. 1.1. What is the ratio of the Unemployed females (as % of female labor force ages 15-24) of Saudi Arabia in 2003 to that in 2007?
Give a very brief answer. 1.14. What is the ratio of the Unemployed females (as % of female labor force ages 15-24) of Honduras in 2004 to that in 2005?
Ensure brevity in your answer.  1.37. What is the ratio of the Unemployed females (as % of female labor force ages 15-24) of Kyrgyz Republic in 2004 to that in 2005?
Give a very brief answer. 1.09. What is the ratio of the Unemployed females (as % of female labor force ages 15-24) of Saudi Arabia in 2004 to that in 2005?
Keep it short and to the point. 1. What is the ratio of the Unemployed females (as % of female labor force ages 15-24) of Honduras in 2004 to that in 2006?
Your response must be concise. 1.95. What is the ratio of the Unemployed females (as % of female labor force ages 15-24) in Kyrgyz Republic in 2004 to that in 2006?
Ensure brevity in your answer.  1.09. What is the ratio of the Unemployed females (as % of female labor force ages 15-24) in Saudi Arabia in 2004 to that in 2006?
Give a very brief answer. 1.04. What is the ratio of the Unemployed females (as % of female labor force ages 15-24) in Honduras in 2004 to that in 2007?
Offer a terse response. 2.08. What is the ratio of the Unemployed females (as % of female labor force ages 15-24) in Kyrgyz Republic in 2004 to that in 2007?
Make the answer very short. 1.06. What is the ratio of the Unemployed females (as % of female labor force ages 15-24) of Saudi Arabia in 2004 to that in 2007?
Make the answer very short. 1.13. What is the ratio of the Unemployed females (as % of female labor force ages 15-24) of Honduras in 2005 to that in 2006?
Your response must be concise. 1.42. What is the ratio of the Unemployed females (as % of female labor force ages 15-24) of Saudi Arabia in 2005 to that in 2006?
Make the answer very short. 1.04. What is the ratio of the Unemployed females (as % of female labor force ages 15-24) in Honduras in 2005 to that in 2007?
Offer a terse response. 1.51. What is the ratio of the Unemployed females (as % of female labor force ages 15-24) in Kyrgyz Republic in 2005 to that in 2007?
Make the answer very short. 0.97. What is the ratio of the Unemployed females (as % of female labor force ages 15-24) in Saudi Arabia in 2005 to that in 2007?
Your answer should be very brief. 1.13. What is the ratio of the Unemployed females (as % of female labor force ages 15-24) in Honduras in 2006 to that in 2007?
Offer a terse response. 1.07. What is the ratio of the Unemployed females (as % of female labor force ages 15-24) of Kyrgyz Republic in 2006 to that in 2007?
Provide a short and direct response. 0.97. What is the ratio of the Unemployed females (as % of female labor force ages 15-24) of Saudi Arabia in 2006 to that in 2007?
Offer a terse response. 1.09. What is the difference between the highest and the second highest Unemployed females (as % of female labor force ages 15-24) of Honduras?
Provide a succinct answer. 3.7. What is the difference between the highest and the second highest Unemployed females (as % of female labor force ages 15-24) of Kyrgyz Republic?
Offer a terse response. 2.7. What is the difference between the highest and the second highest Unemployed females (as % of female labor force ages 15-24) in Saudi Arabia?
Your answer should be very brief. 0.7. What is the difference between the highest and the lowest Unemployed females (as % of female labor force ages 15-24) of Saudi Arabia?
Your response must be concise. 23.2. 